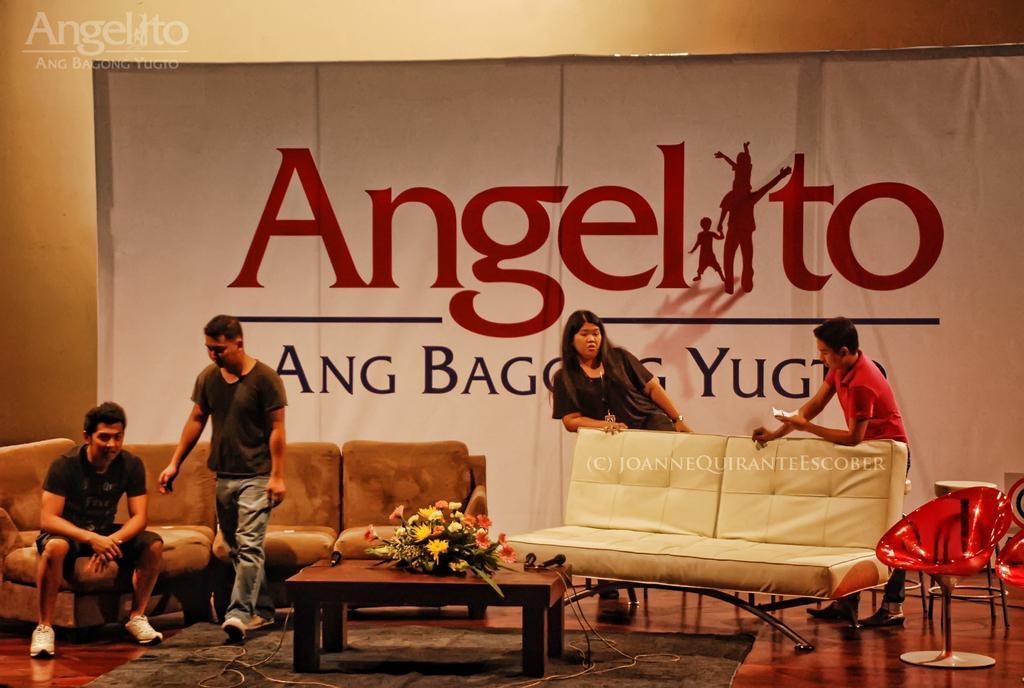Describe this image in one or two sentences. In this image On the right there are two people, in front of them there is a sofa and there are chairs. In the middle there is a table on that there is a flower vase. On the left there are two men on that one man is walking another man is sitting he wear black t shirt, trouser and shoes he is siting on the sofa. In the background there is a poster. 